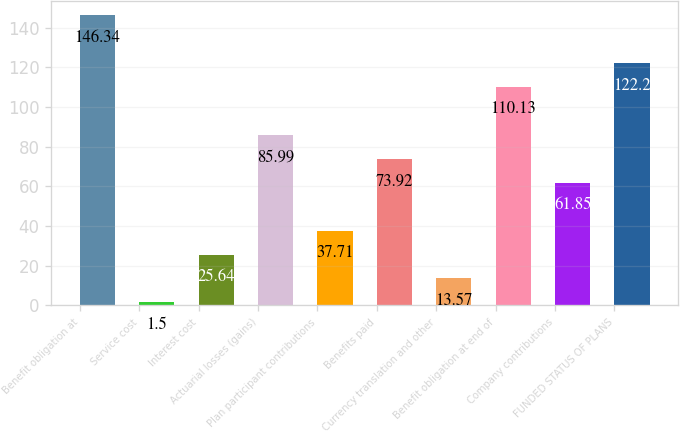<chart> <loc_0><loc_0><loc_500><loc_500><bar_chart><fcel>Benefit obligation at<fcel>Service cost<fcel>Interest cost<fcel>Actuarial losses (gains)<fcel>Plan participant contributions<fcel>Benefits paid<fcel>Currency translation and other<fcel>Benefit obligation at end of<fcel>Company contributions<fcel>FUNDED STATUS OF PLANS<nl><fcel>146.34<fcel>1.5<fcel>25.64<fcel>85.99<fcel>37.71<fcel>73.92<fcel>13.57<fcel>110.13<fcel>61.85<fcel>122.2<nl></chart> 